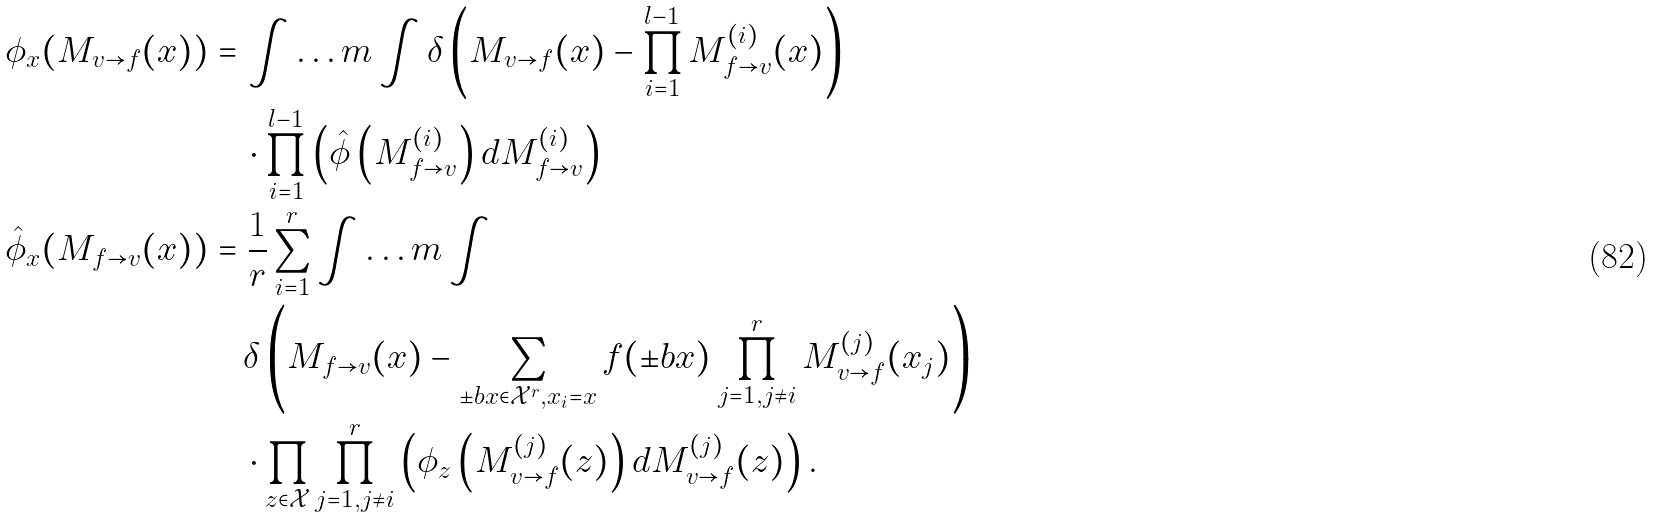<formula> <loc_0><loc_0><loc_500><loc_500>\phi _ { x } ( M _ { v \to f } ( x ) ) & = \int \dots m \int \delta \left ( M _ { v \to f } ( x ) - \prod _ { i = 1 } ^ { l - 1 } M _ { f \to v } ^ { ( i ) } ( x ) \right ) \\ & \quad \cdot \prod _ { i = 1 } ^ { l - 1 } \left ( \hat { \phi } \left ( M _ { f \to v } ^ { ( i ) } \right ) d M _ { f \to v } ^ { ( i ) } \right ) \\ \hat { \phi } _ { x } ( M _ { f \to v } ( x ) ) & = \frac { 1 } { r } \sum _ { i = 1 } ^ { r } \int \dots m \int \\ & \quad \delta \left ( M _ { f \to v } ( x ) - \sum _ { \pm b { x } \in \mathcal { X } ^ { r } , x _ { i } = x } f ( \pm b { x } ) \prod _ { j = 1 , j \ne i } ^ { r } M _ { v \to f } ^ { ( j ) } ( x _ { j } ) \right ) \\ & \quad \cdot \prod _ { z \in \mathcal { X } } \prod _ { j = 1 , j \ne i } ^ { r } \left ( \phi _ { z } \left ( M _ { v \to f } ^ { ( j ) } ( z ) \right ) d M _ { v \to f } ^ { ( j ) } ( z ) \right ) .</formula> 